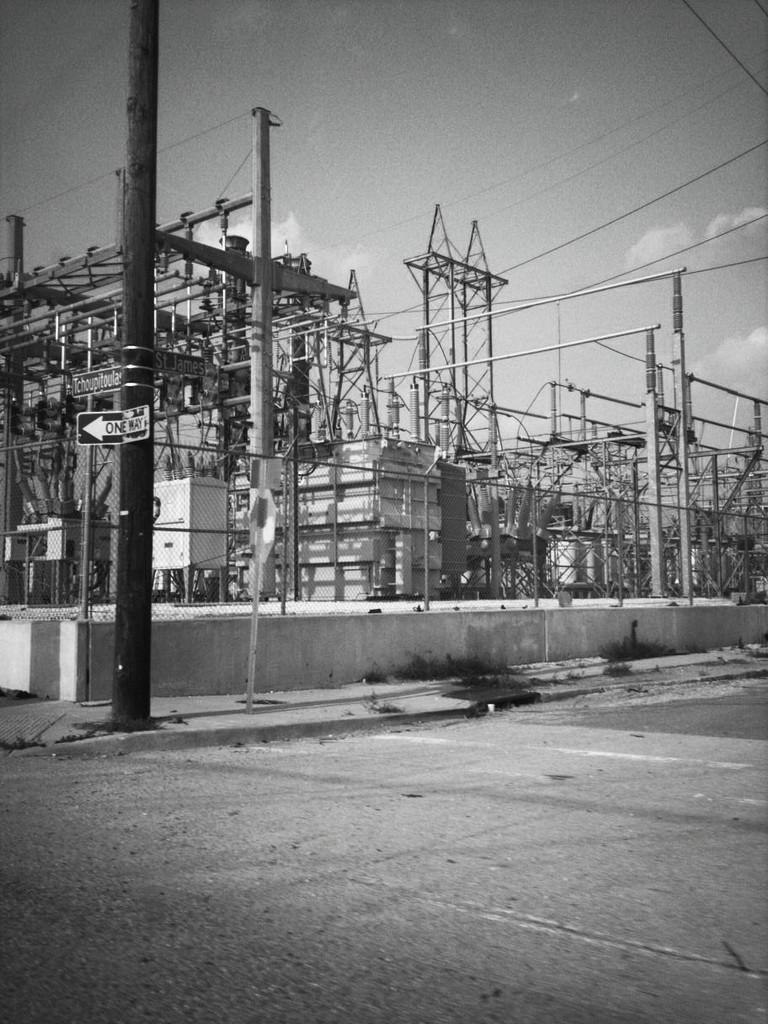Describe this image in one or two sentences. This is black and white picture, in this picture we can see board, poles, fence, wall, wires and electricity substation. In the background of the image we can see the sky with clouds. 